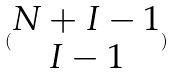<formula> <loc_0><loc_0><loc_500><loc_500>( \begin{matrix} N + I - 1 \\ I - 1 \end{matrix} )</formula> 